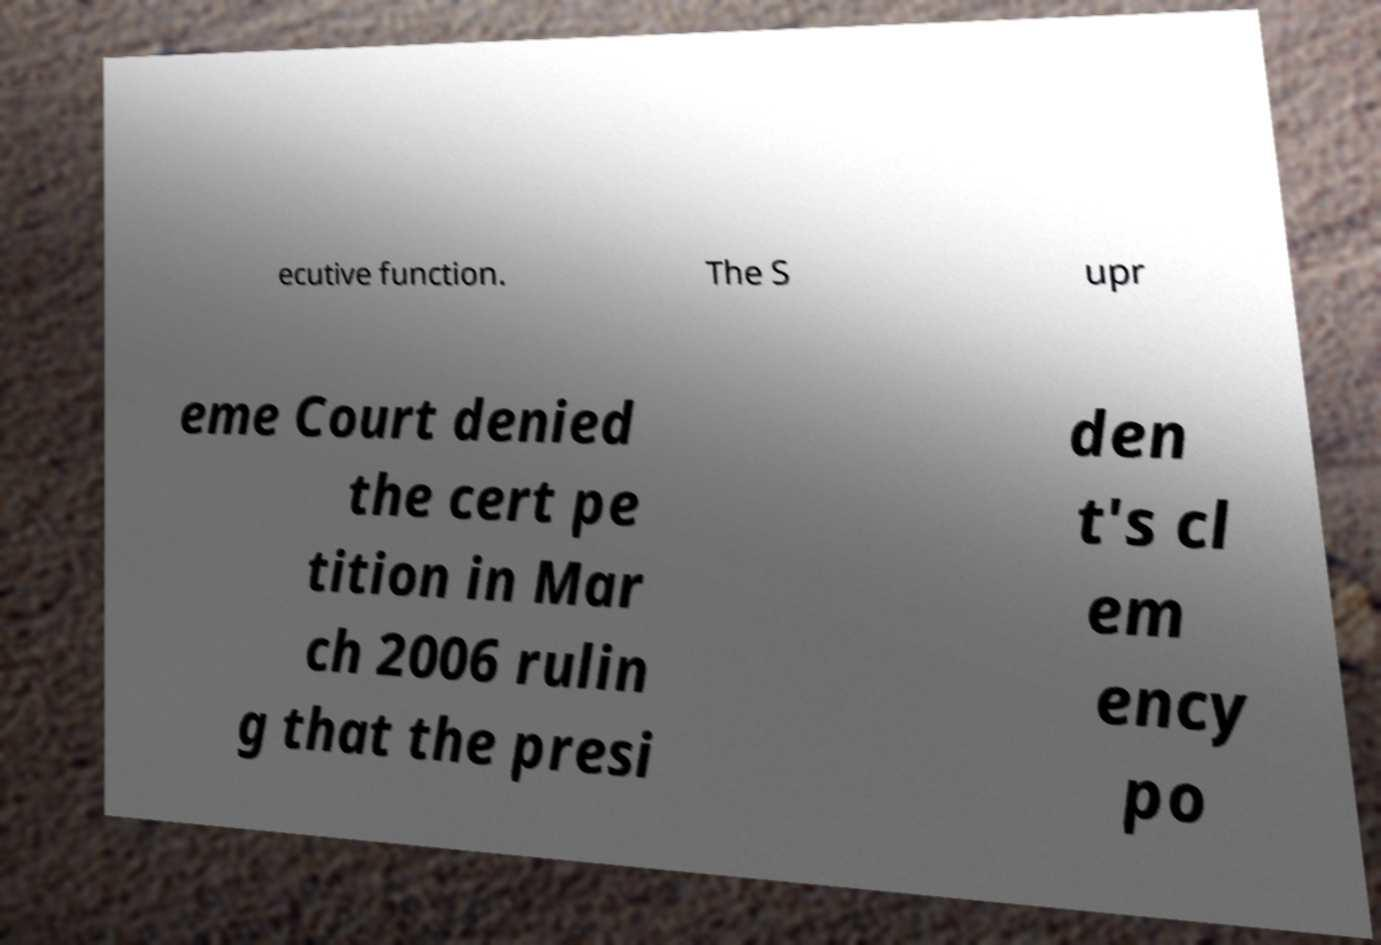Can you accurately transcribe the text from the provided image for me? ecutive function. The S upr eme Court denied the cert pe tition in Mar ch 2006 rulin g that the presi den t's cl em ency po 